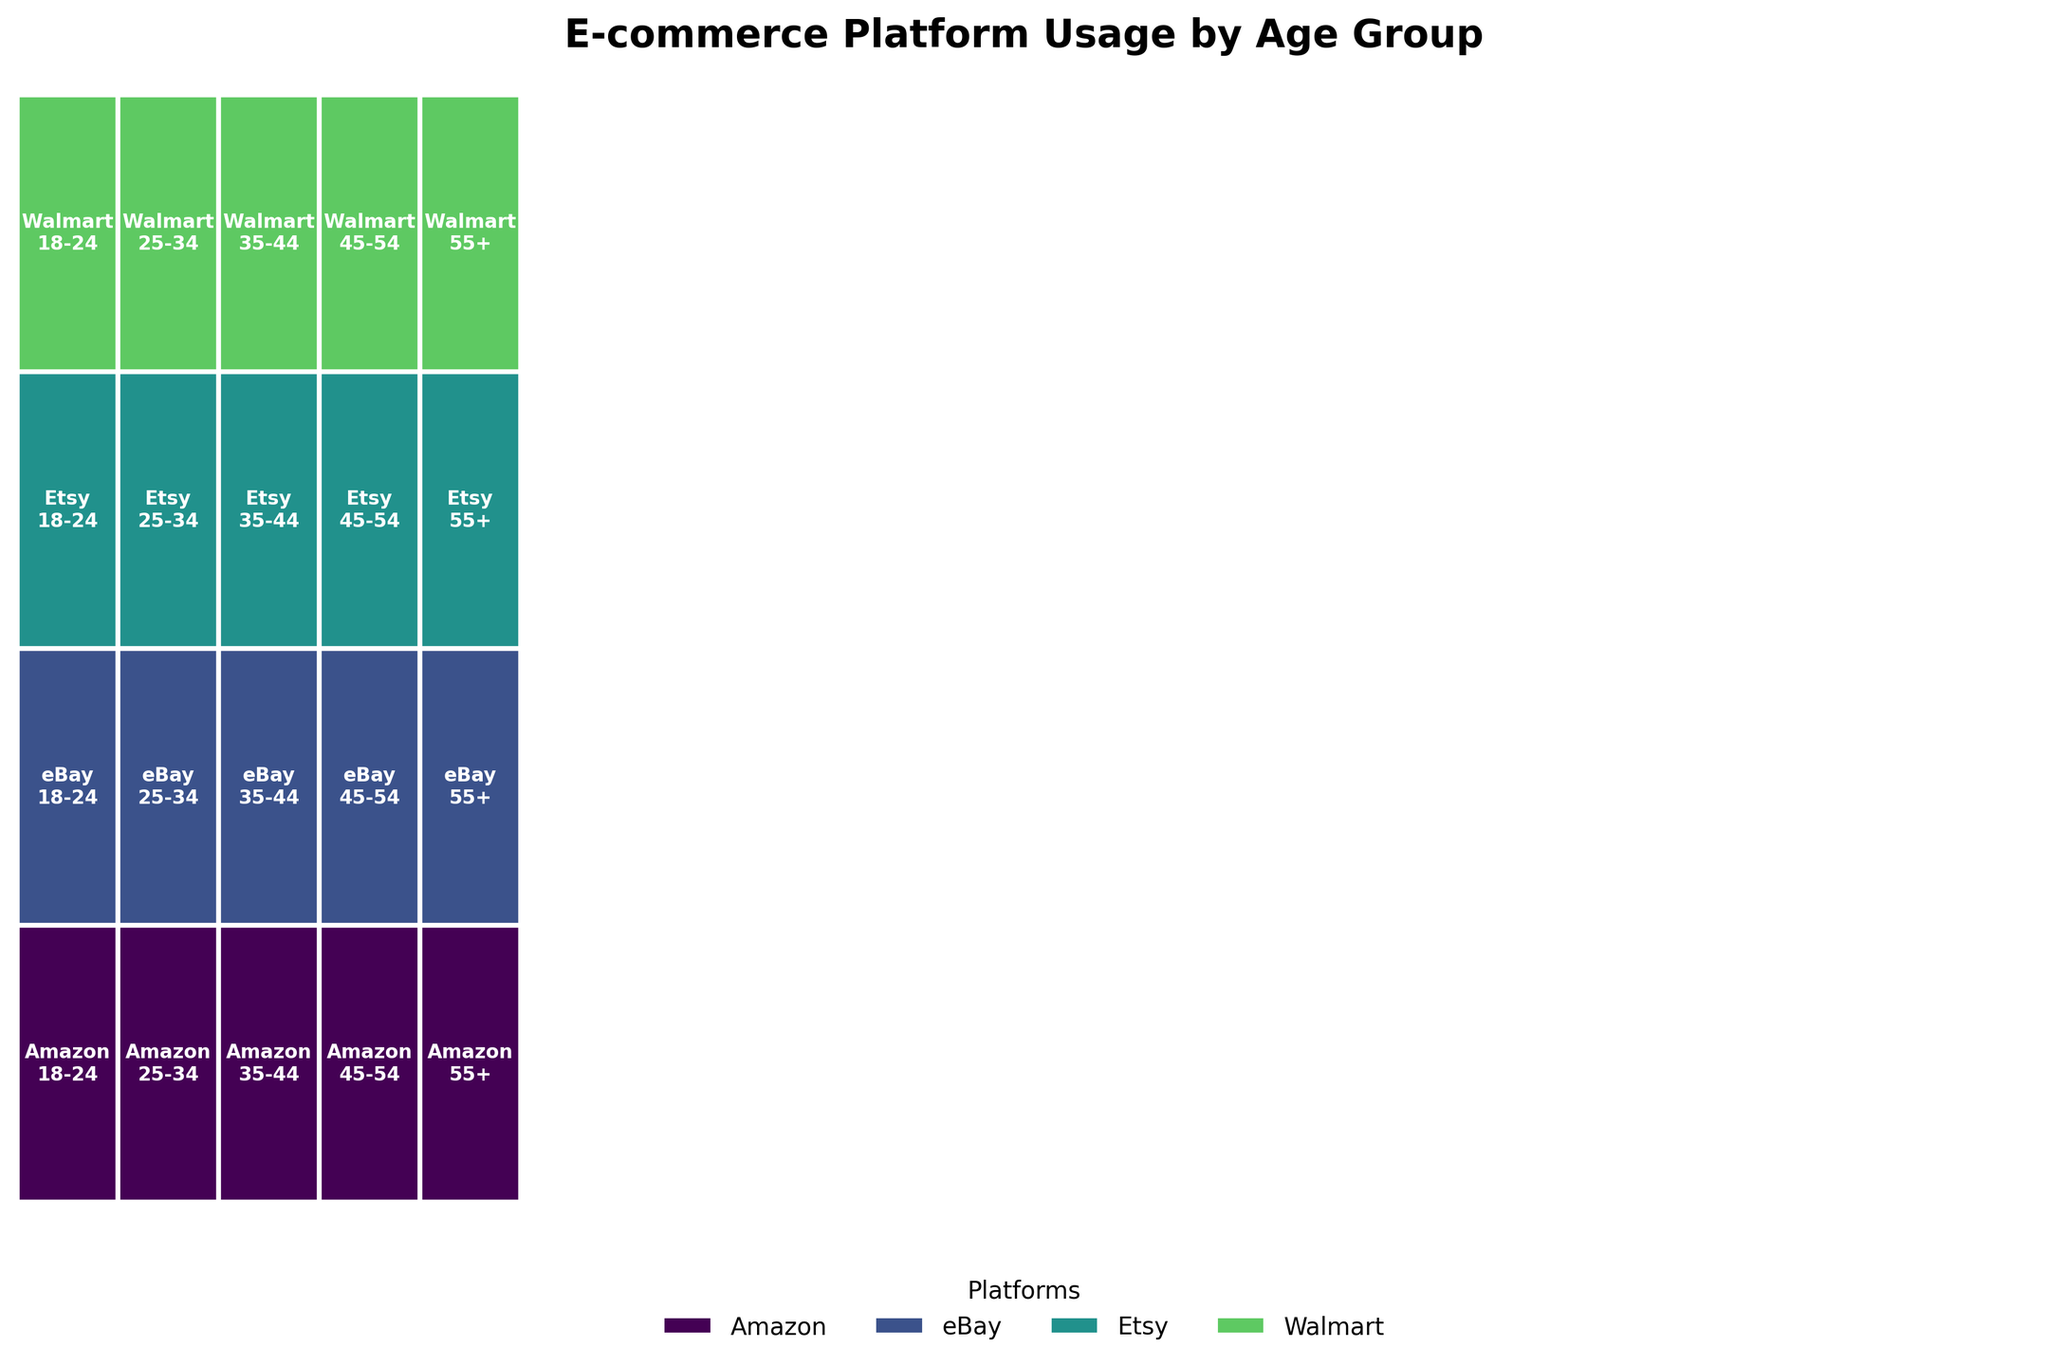How many age groups are depicted in the mosaic plot? The figure includes sections for each age group. By counting all distinct labels for age groups in one platform rectangle, we see there are 5 different age groups depicted.
Answer: 5 Which e-commerce platform appears most frequently across age groups? By observing which platform labels cover the most width across different age group sections, it appears that Amazon and Walmart are frequently depicted across the age groups. Counting the sections, Amazon appears in each of the 5 age groups.
Answer: Amazon Which age group is smallest in terms of purchase frequency? The width of the rectangles represents the fraction of the observation, indicating frequency. The age group with the smallest width across the platforms is 45-54.
Answer: 45-54 Are there any platforms where every age group is represented? Look across the different platforms and count the age group segments within each. Amazon, Etsy, eBay, and Walmart each have segments for all 5 age groups, so every age group is represented in these platforms.
Answer: Yes Do any platforms focus more on a specific age group? By examining the width of the rectangles for each platform across different age groups, it appears that Walmart has a noticeably larger number of customers in the 55+ age group compared to others.
Answer: Walmart Which platform has the most balanced age group distribution? A balanced distribution means each age group has relatively similar widths. Observing the figure, Etsy shows a relatively balanced distribution across all age groups compared to others.
Answer: Etsy For which platform is the 18-24 age group the smallest? By examining the width of the rectangles for the 18-24 age group across each platform, it is smallest for eBay.
Answer: eBay Compare the 25-34 age group between Amazon and Walmart. Which platform has a higher purchase frequency for this age group? Compare the width of the 25-34 segments for Amazon and Walmart directly. Amazon's segment in this age group is wider than Walmart's, indicating a higher purchase frequency.
Answer: Amazon What is the most common age group on Walmart? By observing the width of the age groups within Walmart segments, the widest segment represents the 55+ age group.
Answer: 55+ What trend can be observed about the 18-24 age group across all platforms? By comparing the overall size of the 18-24 segments across all platforms, they tend to have narrower widths, indicating a lower frequency of purchases compared to other age groups.
Answer: Lower purchase frequency 